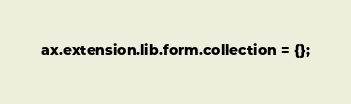<code> <loc_0><loc_0><loc_500><loc_500><_JavaScript_>ax.extension.lib.form.collection = {};
</code> 